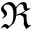<formula> <loc_0><loc_0><loc_500><loc_500>\Re</formula> 